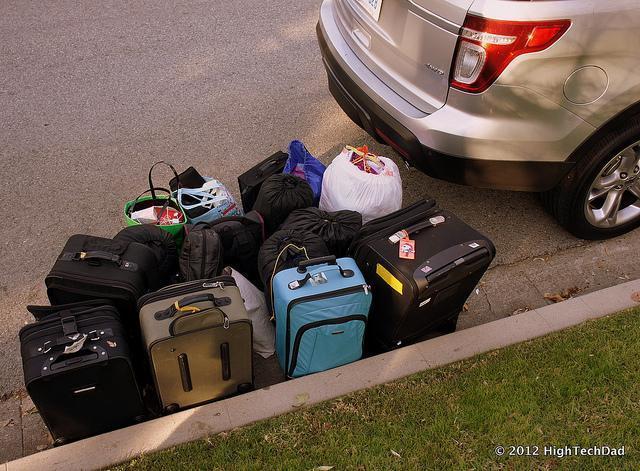How many white bags are there?
Give a very brief answer. 1. How many suitcases are there?
Give a very brief answer. 5. How many backpacks are there?
Give a very brief answer. 1. How many handbags are there?
Give a very brief answer. 2. 